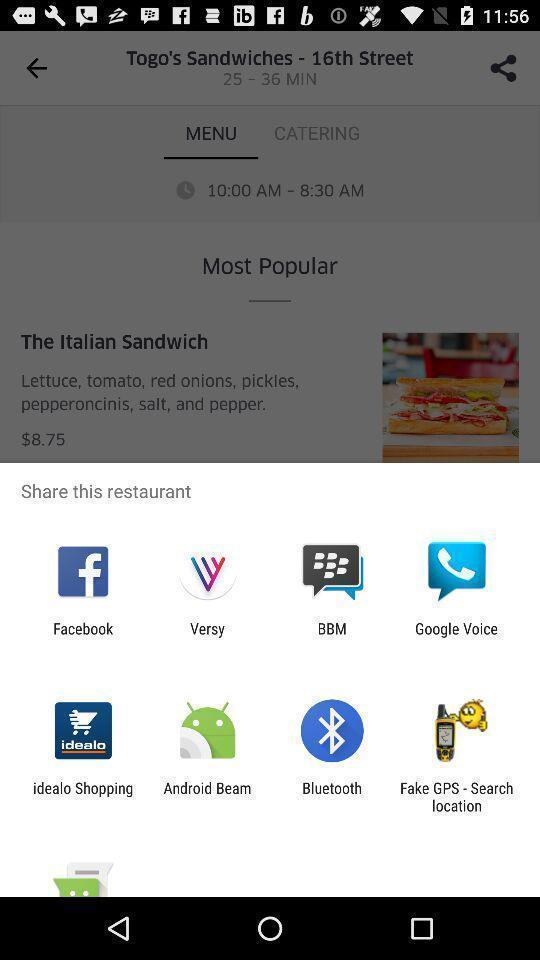Give me a narrative description of this picture. Screen showing various sharing options. 